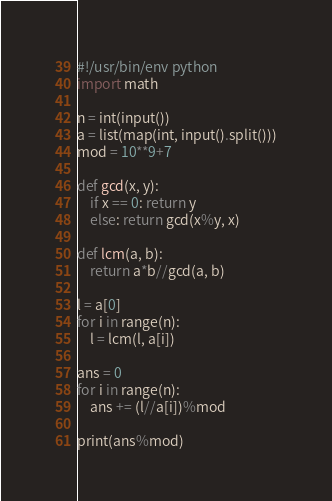<code> <loc_0><loc_0><loc_500><loc_500><_Python_>#!/usr/bin/env python
import math

n = int(input())
a = list(map(int, input().split()))
mod = 10**9+7

def gcd(x, y): 
    if x == 0: return y
    else: return gcd(x%y, x)

def lcm(a, b): 
    return a*b//gcd(a, b)

l = a[0]
for i in range(n):
    l = lcm(l, a[i])

ans = 0 
for i in range(n):
    ans += (l//a[i])%mod

print(ans%mod)
</code> 